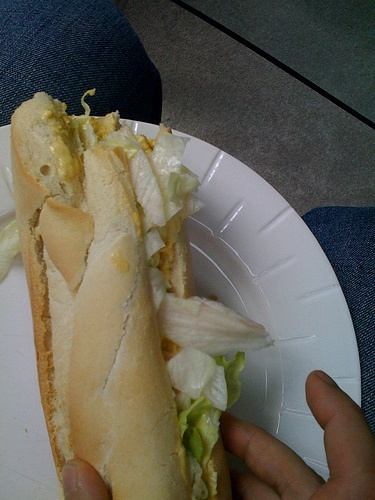Describe the objects in this image and their specific colors. I can see sandwich in navy, tan, olive, and darkgray tones and people in navy, maroon, black, and gray tones in this image. 